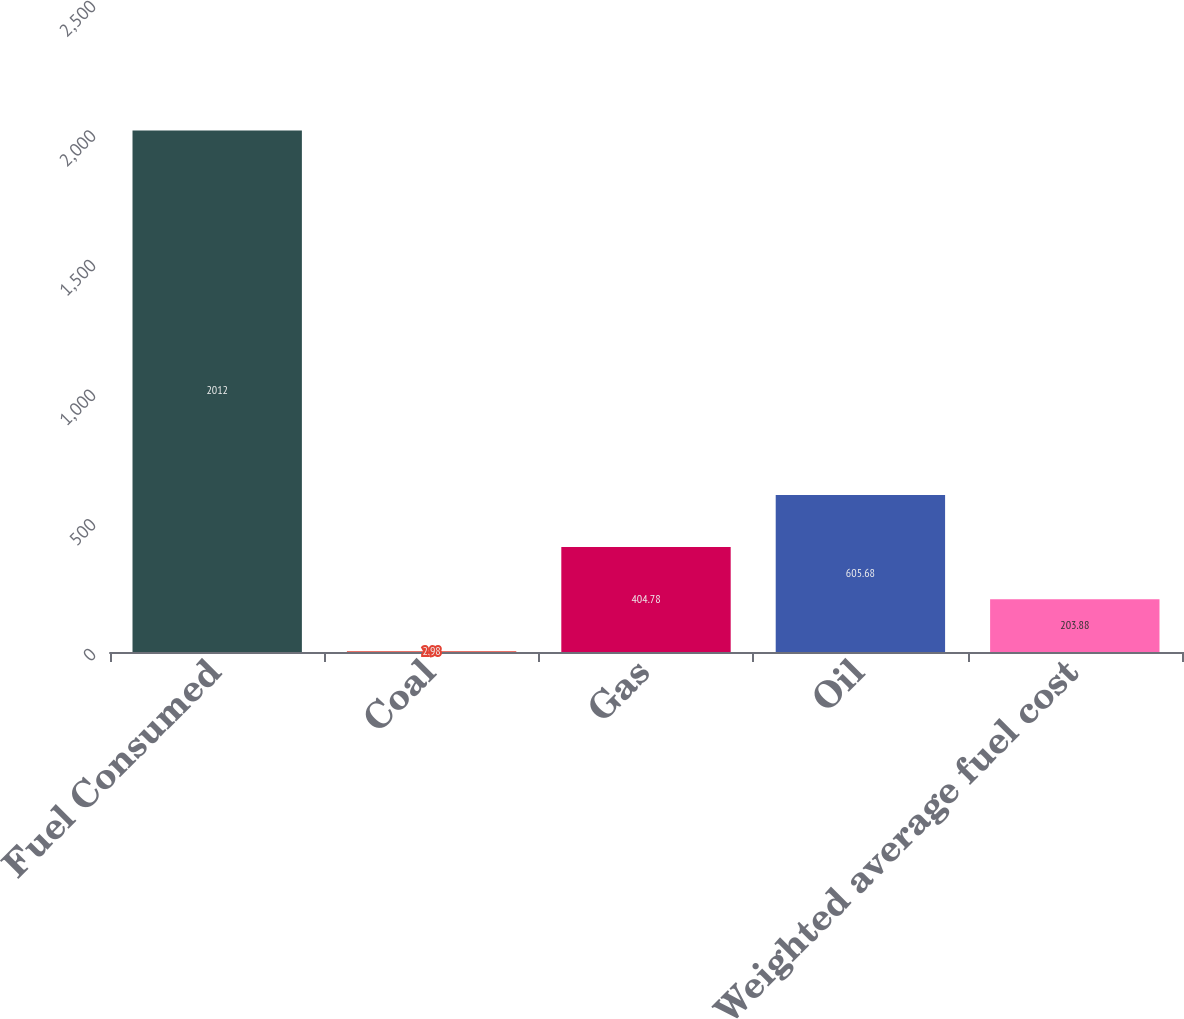<chart> <loc_0><loc_0><loc_500><loc_500><bar_chart><fcel>Fuel Consumed<fcel>Coal<fcel>Gas<fcel>Oil<fcel>Weighted average fuel cost<nl><fcel>2012<fcel>2.98<fcel>404.78<fcel>605.68<fcel>203.88<nl></chart> 